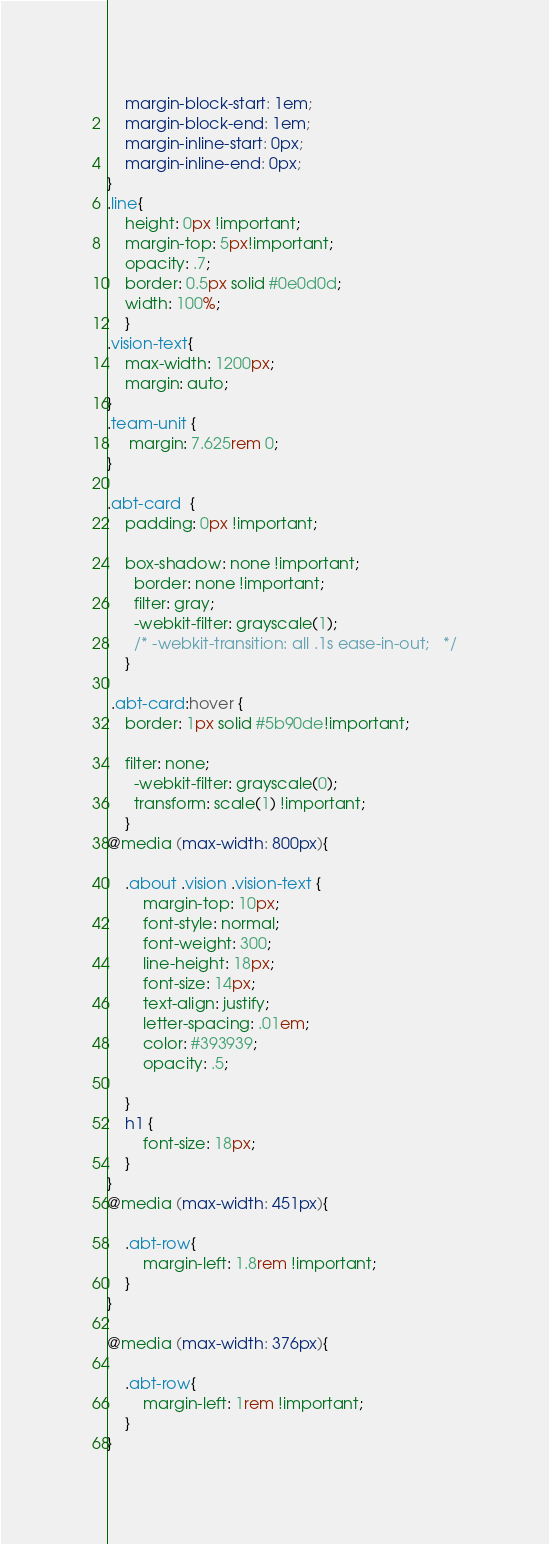<code> <loc_0><loc_0><loc_500><loc_500><_CSS_>    margin-block-start: 1em;
    margin-block-end: 1em;
    margin-inline-start: 0px;
    margin-inline-end: 0px;
}
.line{
    height: 0px !important;
    margin-top: 5px!important;
    opacity: .7;
    border: 0.5px solid #0e0d0d;
    width: 100%;
    }
.vision-text{
    max-width: 1200px;
    margin: auto;
}
.team-unit { 
     margin: 7.625rem 0;
}

.abt-card  {
    padding: 0px !important;

    box-shadow: none !important;
      border: none !important;
      filter: gray; 
      -webkit-filter: grayscale(1); 
      /* -webkit-transition: all .1s ease-in-out;   */
    }

 .abt-card:hover {
    border: 1px solid #5b90de!important;

    filter: none;
      -webkit-filter: grayscale(0);
      transform: scale(1) !important;
    }
@media (max-width: 800px){
    
    .about .vision .vision-text {
        margin-top: 10px;
        font-style: normal;
        font-weight: 300;
        line-height: 18px;
        font-size: 14px;
        text-align: justify;
        letter-spacing: .01em;
        color: #393939;
        opacity: .5;
        
    }
    h1 {
        font-size: 18px;
    }
}
@media (max-width: 451px){
    
    .abt-row{
        margin-left: 1.8rem !important;
    }
}

@media (max-width: 376px){
    
    .abt-row{
        margin-left: 1rem !important;
    }
}</code> 